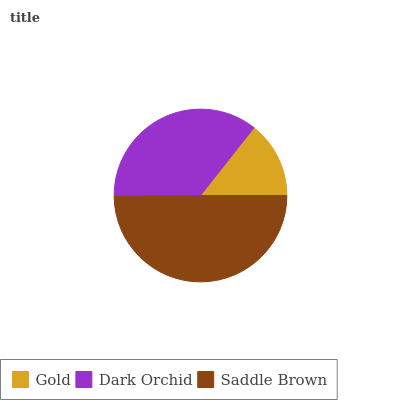Is Gold the minimum?
Answer yes or no. Yes. Is Saddle Brown the maximum?
Answer yes or no. Yes. Is Dark Orchid the minimum?
Answer yes or no. No. Is Dark Orchid the maximum?
Answer yes or no. No. Is Dark Orchid greater than Gold?
Answer yes or no. Yes. Is Gold less than Dark Orchid?
Answer yes or no. Yes. Is Gold greater than Dark Orchid?
Answer yes or no. No. Is Dark Orchid less than Gold?
Answer yes or no. No. Is Dark Orchid the high median?
Answer yes or no. Yes. Is Dark Orchid the low median?
Answer yes or no. Yes. Is Saddle Brown the high median?
Answer yes or no. No. Is Saddle Brown the low median?
Answer yes or no. No. 